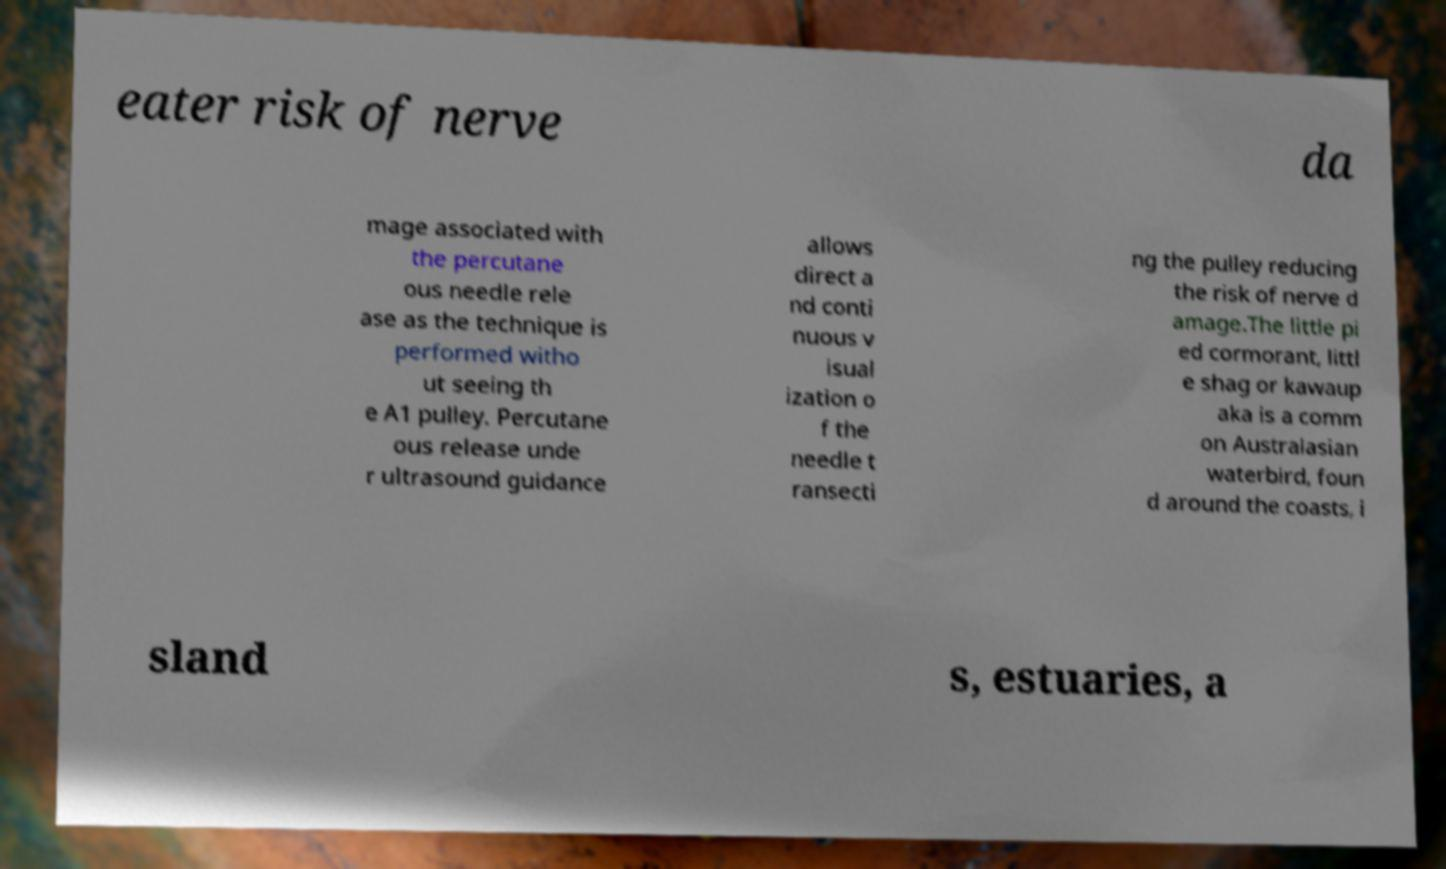For documentation purposes, I need the text within this image transcribed. Could you provide that? eater risk of nerve da mage associated with the percutane ous needle rele ase as the technique is performed witho ut seeing th e A1 pulley. Percutane ous release unde r ultrasound guidance allows direct a nd conti nuous v isual ization o f the needle t ransecti ng the pulley reducing the risk of nerve d amage.The little pi ed cormorant, littl e shag or kawaup aka is a comm on Australasian waterbird, foun d around the coasts, i sland s, estuaries, a 